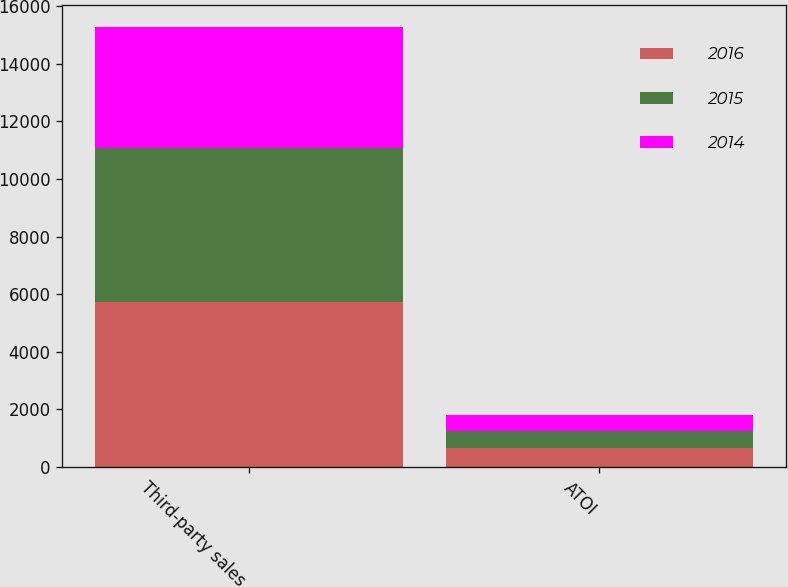<chart> <loc_0><loc_0><loc_500><loc_500><stacked_bar_chart><ecel><fcel>Third-party sales<fcel>ATOI<nl><fcel>2016<fcel>5728<fcel>642<nl><fcel>2015<fcel>5342<fcel>595<nl><fcel>2014<fcel>4217<fcel>579<nl></chart> 